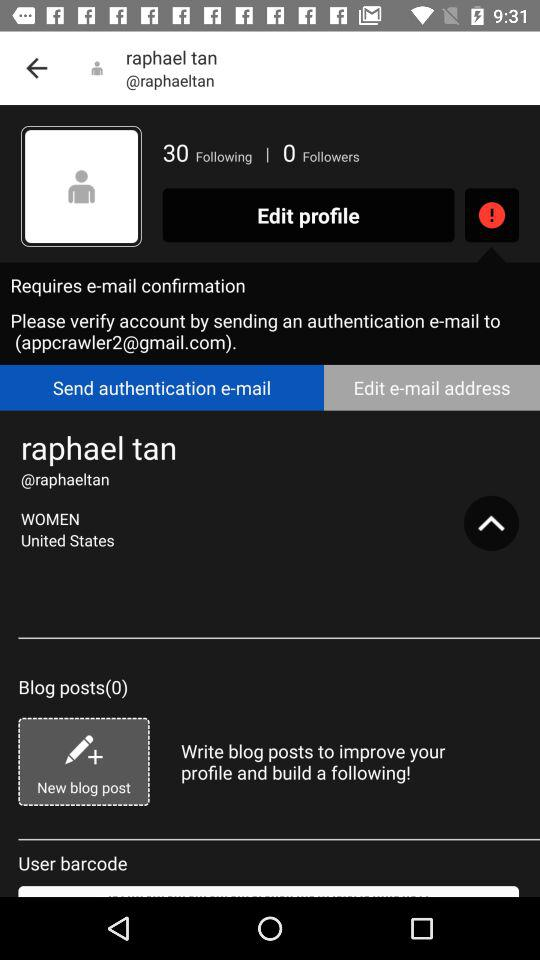How many followers are there? There are 0 followers. 